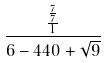<formula> <loc_0><loc_0><loc_500><loc_500>\frac { \frac { \frac { 7 } { 7 } } { 1 } } { 6 - 4 4 0 + \sqrt { 9 } }</formula> 